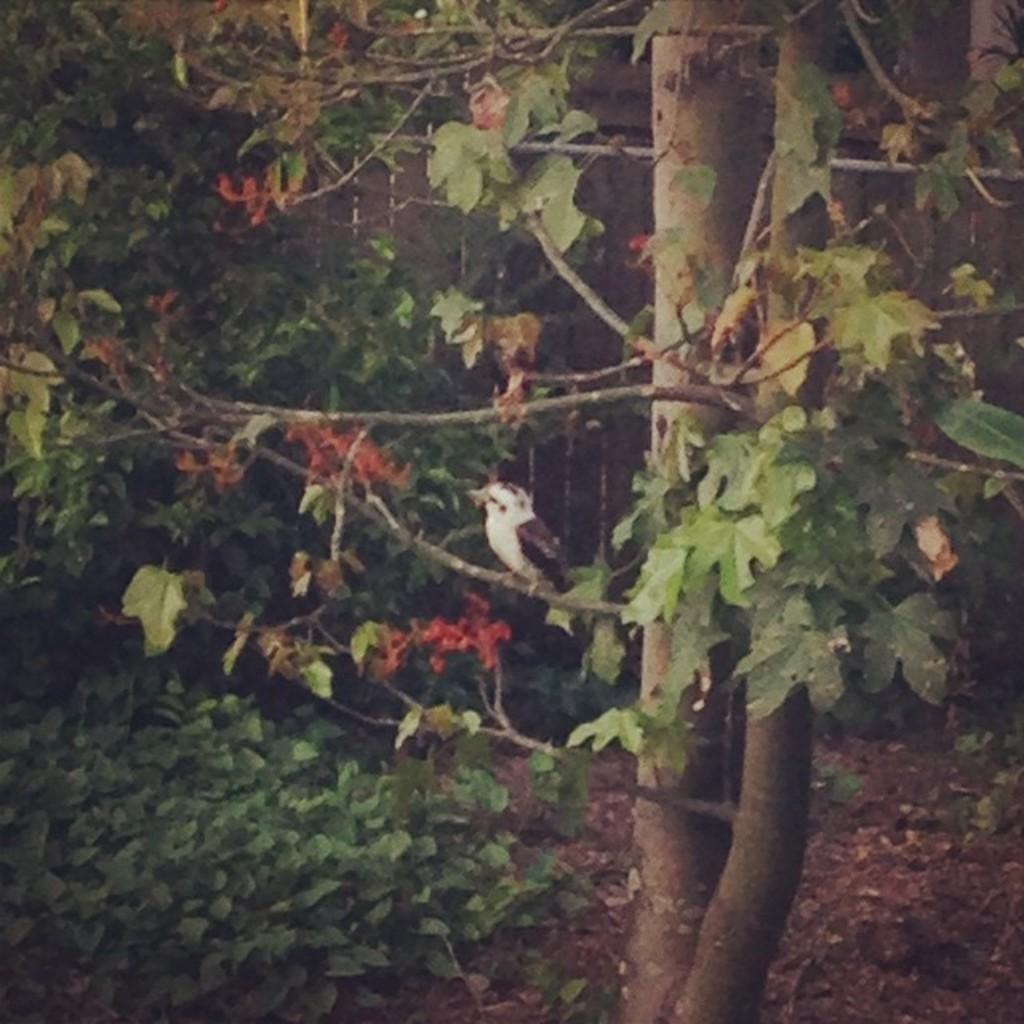What type of vegetation can be seen in the image? There are trees and plants in the image. Can you describe the background of the image? There is a building in the background of the image. Did the plants in the image receive approval for their stitching techniques? There is no indication of stitching or approval in the image, as it features trees and plants without any reference to such activities. 